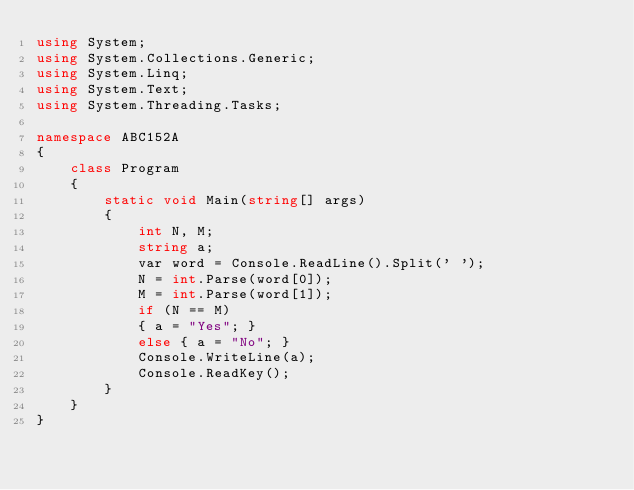<code> <loc_0><loc_0><loc_500><loc_500><_C#_>using System;
using System.Collections.Generic;
using System.Linq;
using System.Text;
using System.Threading.Tasks;

namespace ABC152A
{
    class Program
    {
        static void Main(string[] args)
        {
            int N, M;
            string a;
            var word = Console.ReadLine().Split(' ');
            N = int.Parse(word[0]);
            M = int.Parse(word[1]);
            if (N == M)
            { a = "Yes"; }
            else { a = "No"; }
            Console.WriteLine(a);
            Console.ReadKey();
        }
    }
}
</code> 